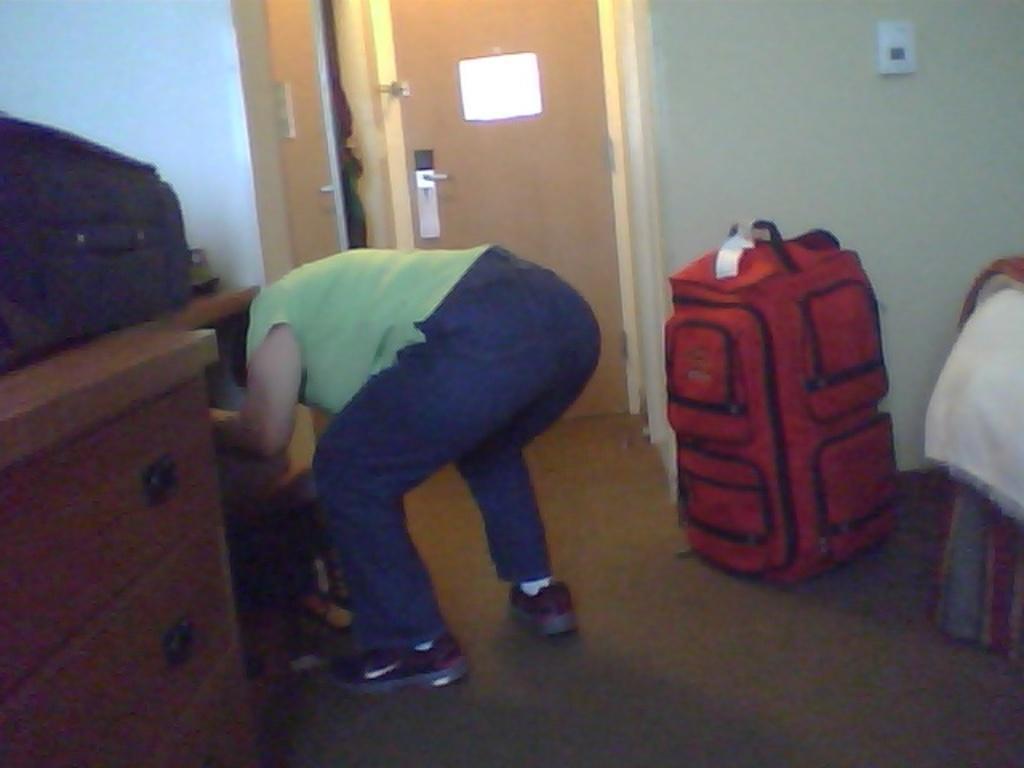Please provide a concise description of this image. In this picture we can see one person bending. At the right side of the picture we can see a red bag. This is a wall. This is a door and at the left side of the picture we can see a desk and a luggage bag on the desk. 